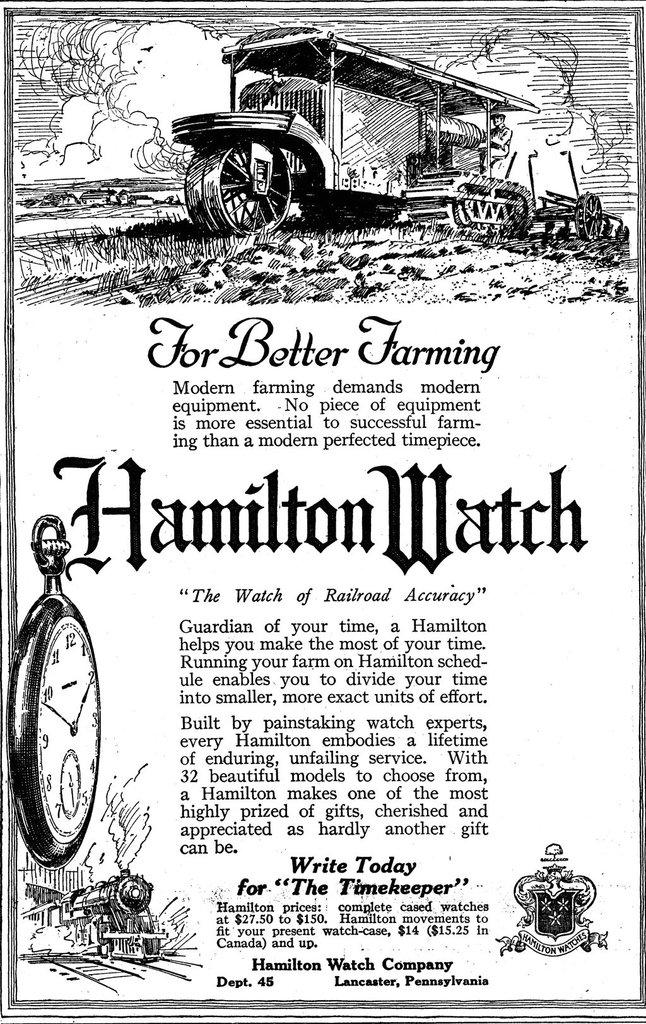Provide a one-sentence caption for the provided image. An illustration with an article called for better farming. 